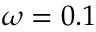Convert formula to latex. <formula><loc_0><loc_0><loc_500><loc_500>\omega = 0 . 1</formula> 